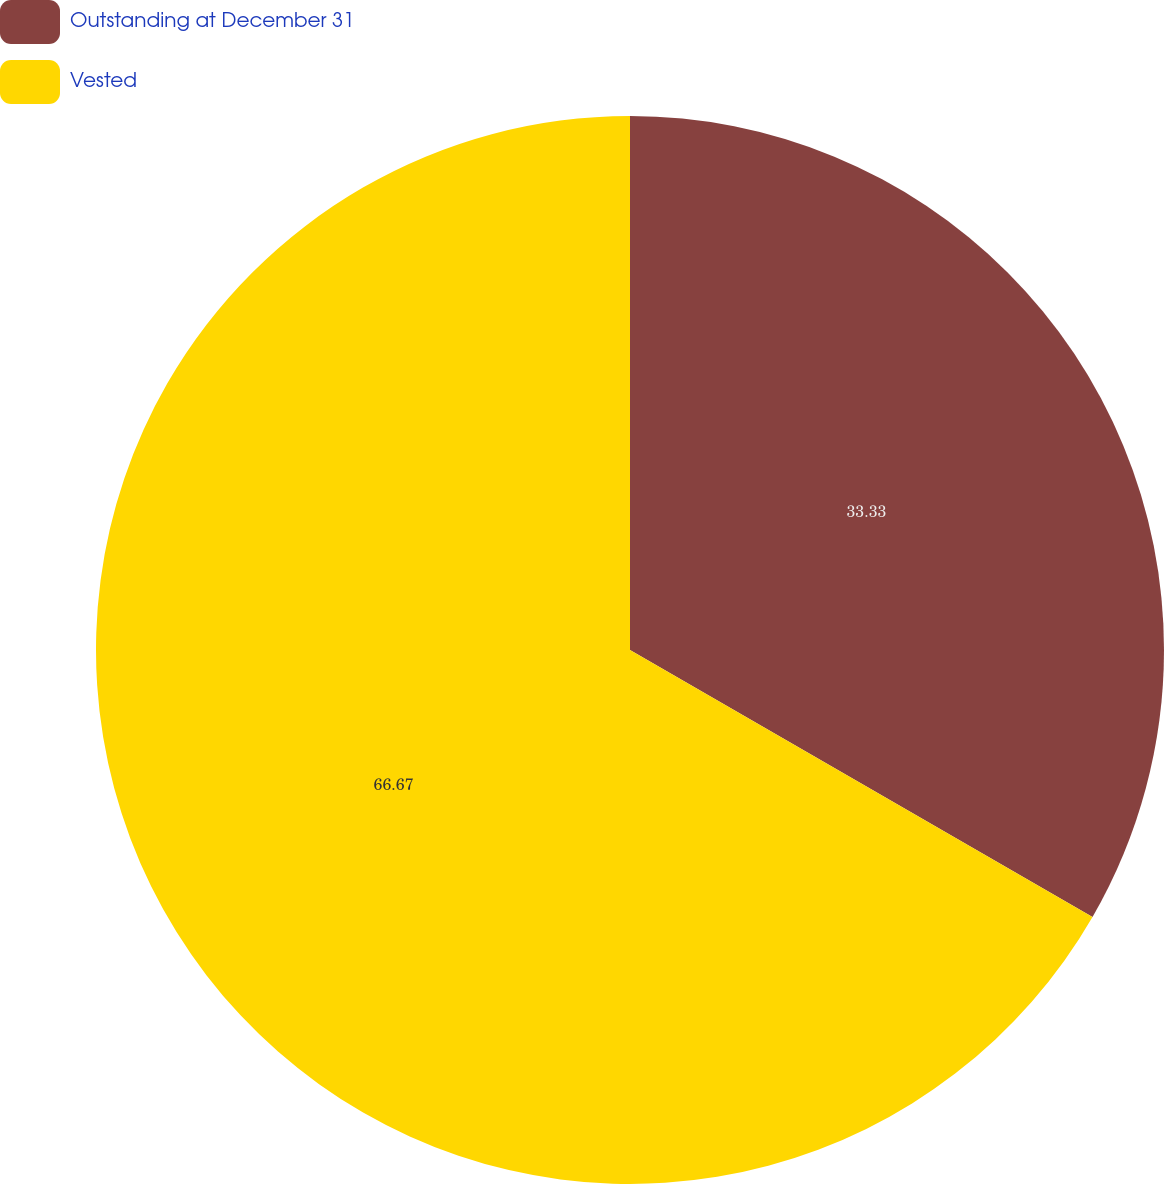Convert chart. <chart><loc_0><loc_0><loc_500><loc_500><pie_chart><fcel>Outstanding at December 31<fcel>Vested<nl><fcel>33.33%<fcel>66.67%<nl></chart> 